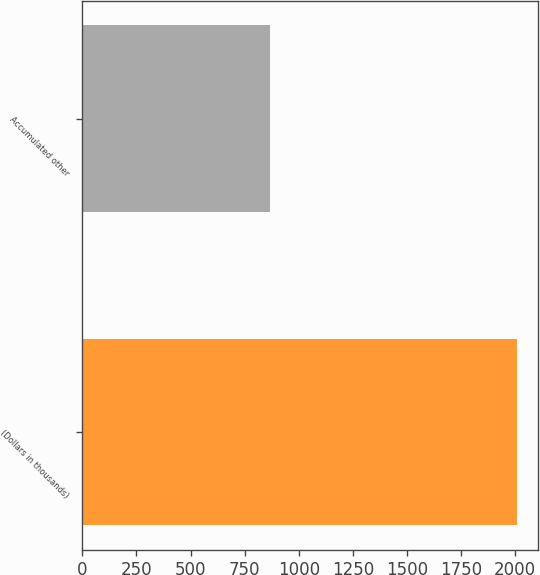<chart> <loc_0><loc_0><loc_500><loc_500><bar_chart><fcel>(Dollars in thousands)<fcel>Accumulated other<nl><fcel>2006<fcel>867<nl></chart> 